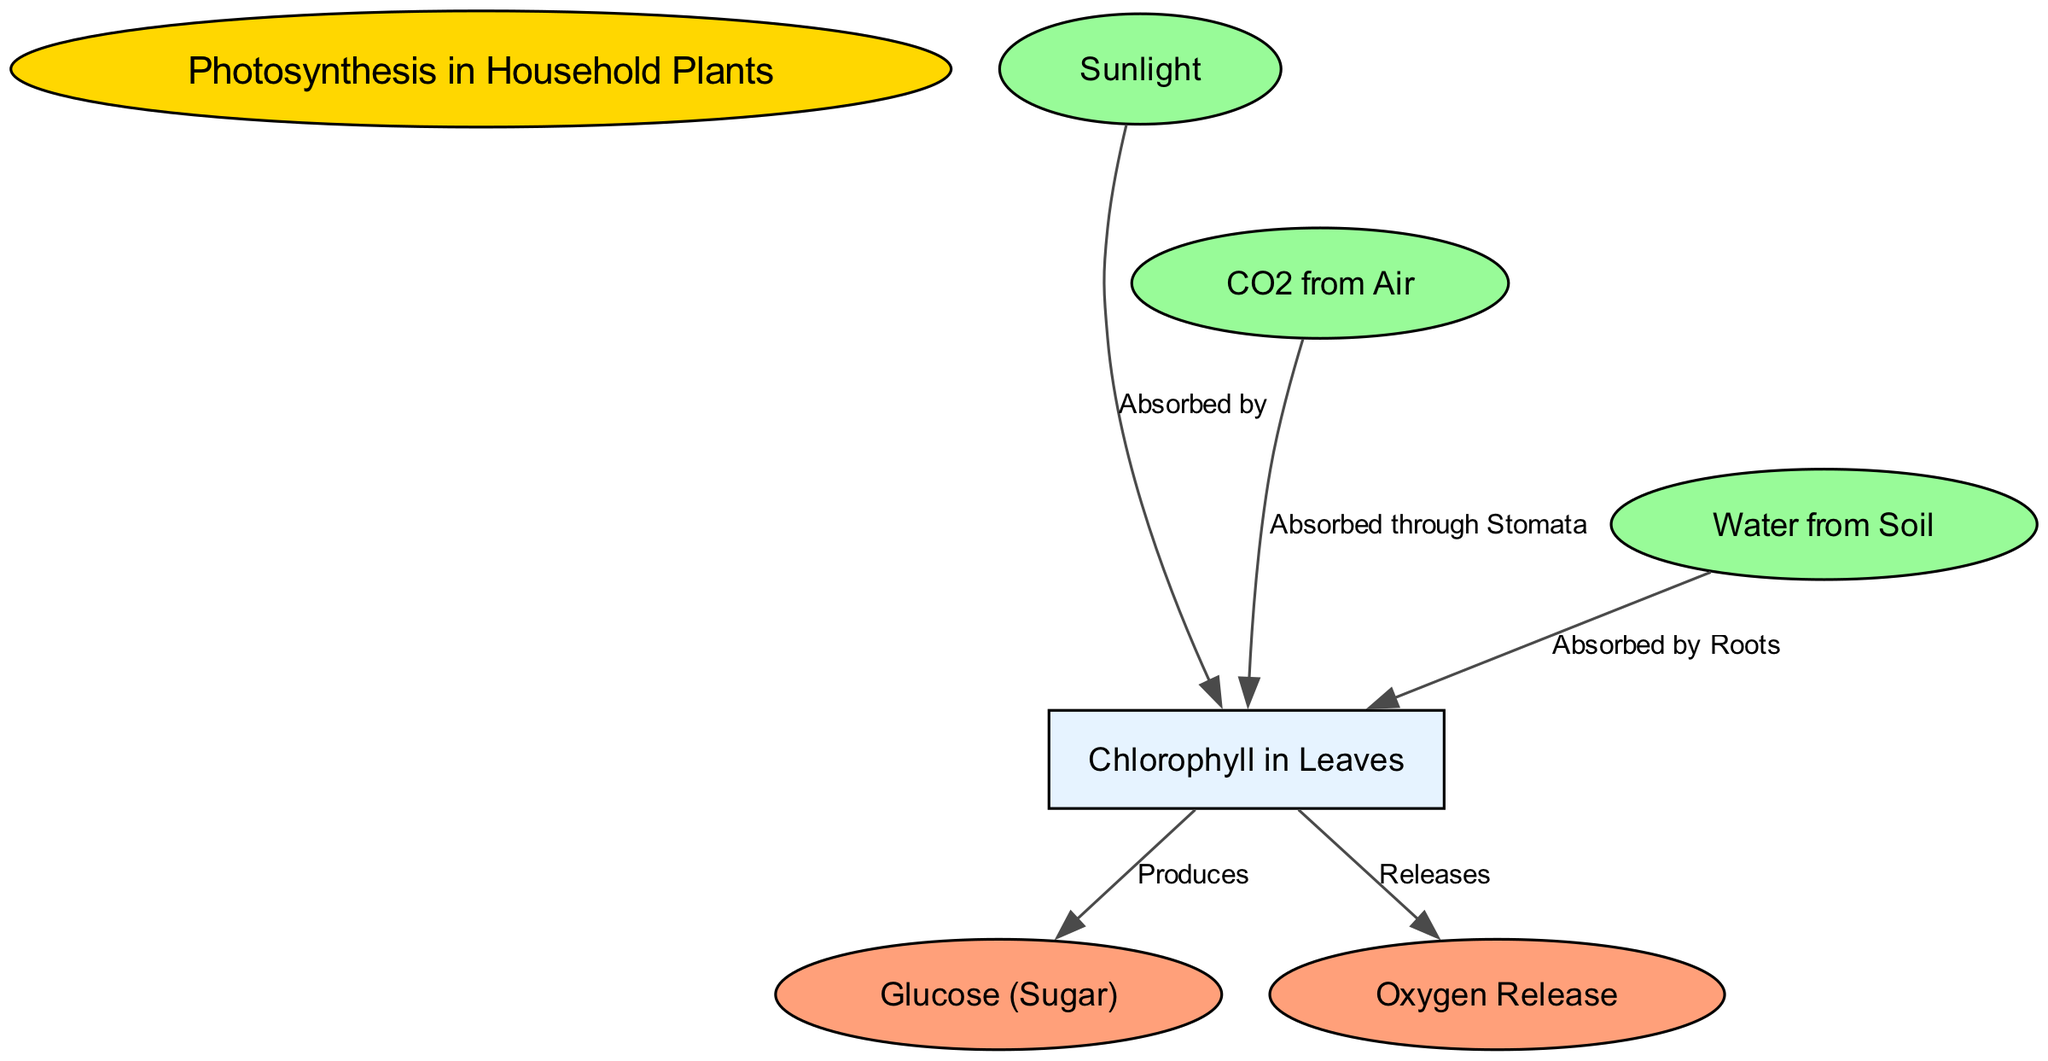What is the primary process illustrated in the diagram? The diagram focuses on photosynthesis, which is the process by which household plants convert light energy into chemical energy. This is derived from the title of the diagram, which clearly states "Photosynthesis in Household Plants".
Answer: Photosynthesis How many nodes are present in the diagram? By counting the nodes in the data provided, there are a total of 7 nodes represented: "Photosynthesis in Household Plants", "Sunlight", "Chlorophyll in Leaves", "CO2 from Air", "Water from Soil", "Glucose (Sugar)", and "Oxygen Release".
Answer: 7 What does sunlight do in the photosynthesis process? The edge from "Sunlight" to "Chlorophyll in Leaves" shows that sunlight is absorbed by chlorophyll, indicating its essential role in photosynthesis.
Answer: Absorbed by How is water acquired by the plant? The relationship between "Water from Soil" and "Chlorophyll in Leaves" indicates that water is absorbed by the roots of the plant to facilitate photosynthesis.
Answer: Absorbed by Roots What two products are produced in the chlorophyll during photosynthesis? The diagram indicates that chlorophyll produces two outputs: glucose and oxygen, linked from the chlorophyll node. This is confirmed by the edges leaving the chlorophyll node.
Answer: Glucose (Sugar) and Oxygen Release What is the purpose of carbon dioxide in the photosynthesis process? The diagram illustrates that carbon dioxide is absorbed through the stomata of the leaves which then combines with the other inputs within chlorophyll to aid the production of glucose and oxygen.
Answer: Absorbed through Stomata Which substance is released as a byproduct of photosynthesis? As shown in the diagram, the chlorophyll releases oxygen as a byproduct of the photosynthesis process. This is indicated by the directed edge from chlorophyll to oxygen.
Answer: Oxygen Release What connects sunlight, water, and carbon dioxide to chlorophyll? The diagram illustrates that sunlight, water, and carbon dioxide all relate to chlorophyll through respective absorption processes that are foundational to photosynthesis, indicating a direct dependence on chlorophyll.
Answer: Absorbed by Which node serves as the main energy source for the photosynthesis process? Observing the diagram, it is clear that sunlight is serving as the primary energy source in the photosynthesis process. The connection from "Sunlight" to "Chlorophyll" indicates this key role.
Answer: Sunlight 